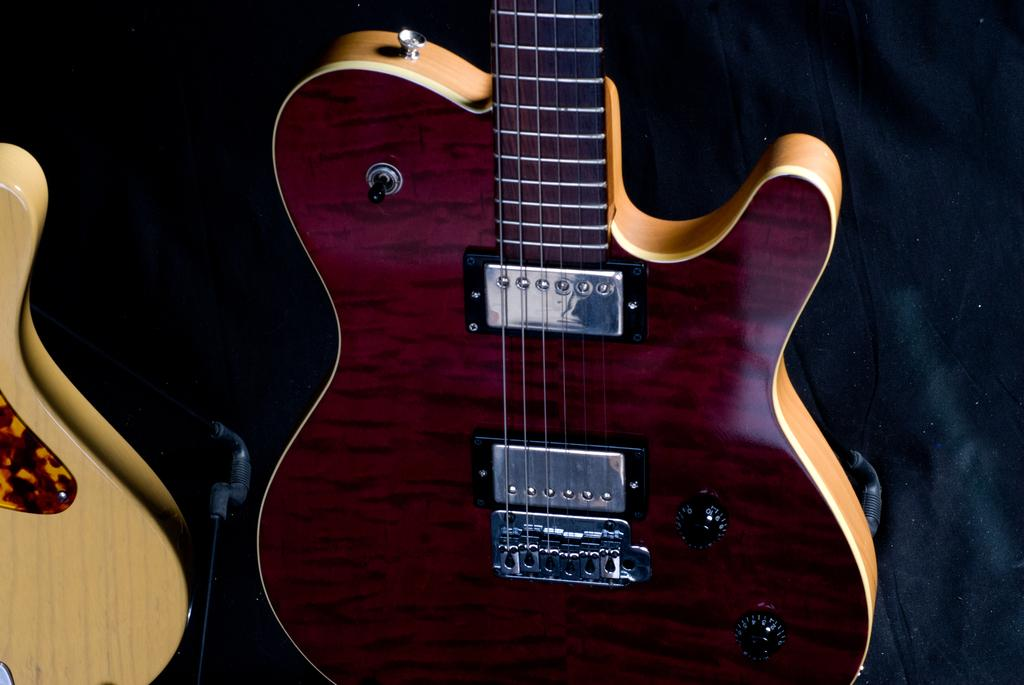What musical instruments are present in the image? There are two guitars in the image. What type of lumber is used to make the guitars in the image? There is no information provided about the materials used to make the guitars, and therefore we cannot determine the type of lumber used. What kind of business is being conducted in the image? There is no indication of any business activity in the image; it simply features two guitars. 